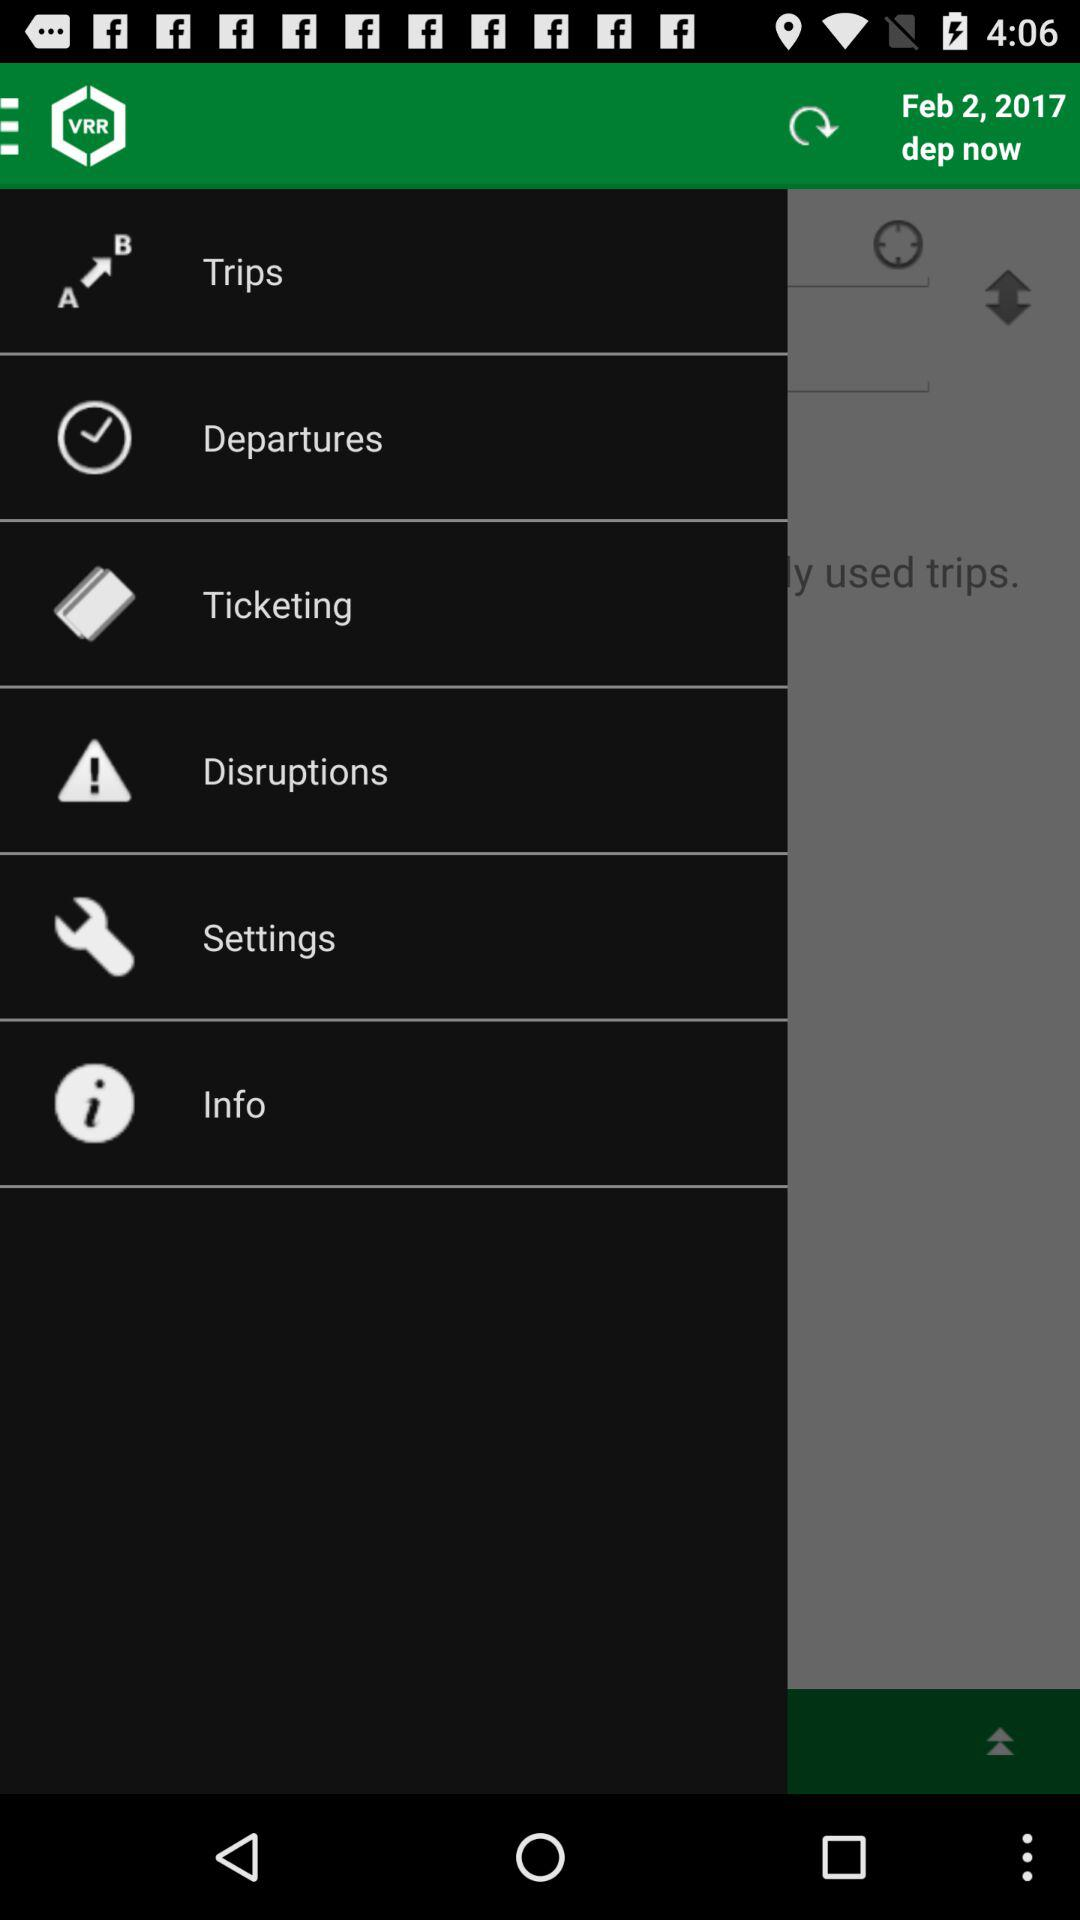What is the departure date? The departure date is February 2, 2017. 